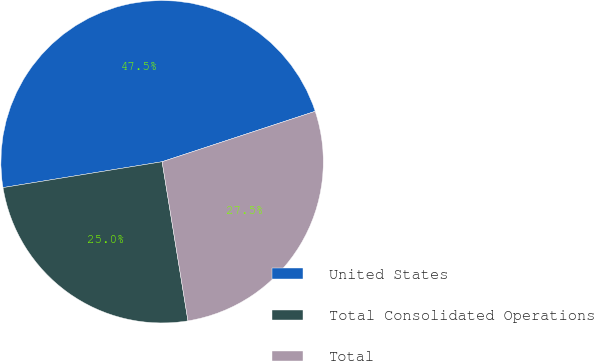Convert chart to OTSL. <chart><loc_0><loc_0><loc_500><loc_500><pie_chart><fcel>United States<fcel>Total Consolidated Operations<fcel>Total<nl><fcel>47.5%<fcel>25.0%<fcel>27.5%<nl></chart> 